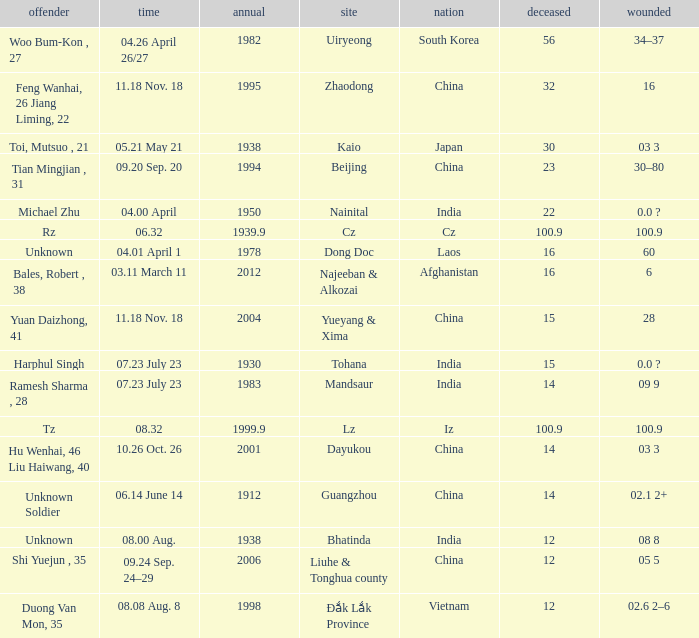What is Country, when Killed is "100.9", and when Year is greater than 1939.9? Iz. 